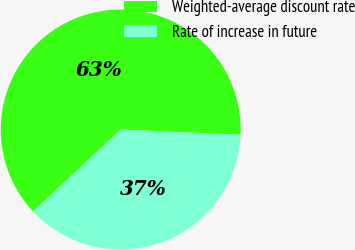Convert chart to OTSL. <chart><loc_0><loc_0><loc_500><loc_500><pie_chart><fcel>Weighted-average discount rate<fcel>Rate of increase in future<nl><fcel>62.65%<fcel>37.35%<nl></chart> 